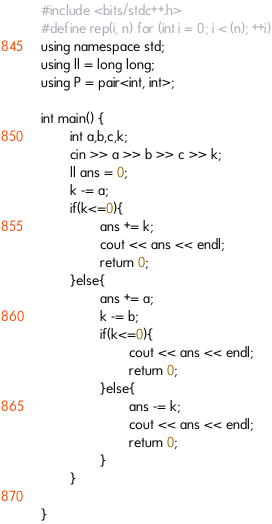<code> <loc_0><loc_0><loc_500><loc_500><_C++_>#include <bits/stdc++.h>
#define rep(i, n) for (int i = 0; i < (n); ++i)
using namespace std;
using ll = long long;
using P = pair<int, int>;

int main() {
        int a,b,c,k;
        cin >> a >> b >> c >> k;
        ll ans = 0;
        k -= a;
        if(k<=0){
                ans += k;
                cout << ans << endl;
                return 0;
        }else{
                ans += a;
                k -= b;
                if(k<=0){
                        cout << ans << endl;
                        return 0;
                }else{
                        ans -= k;
                        cout << ans << endl;
                        return 0;
                }
        }

}</code> 